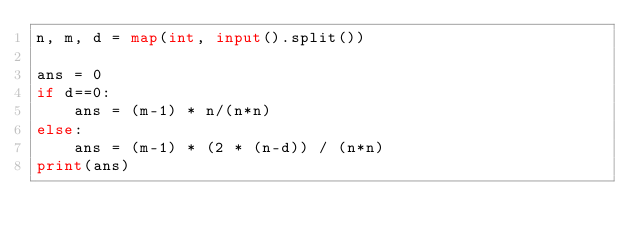Convert code to text. <code><loc_0><loc_0><loc_500><loc_500><_Python_>n, m, d = map(int, input().split())

ans = 0
if d==0:
    ans = (m-1) * n/(n*n)
else:
    ans = (m-1) * (2 * (n-d)) / (n*n)
print(ans)</code> 